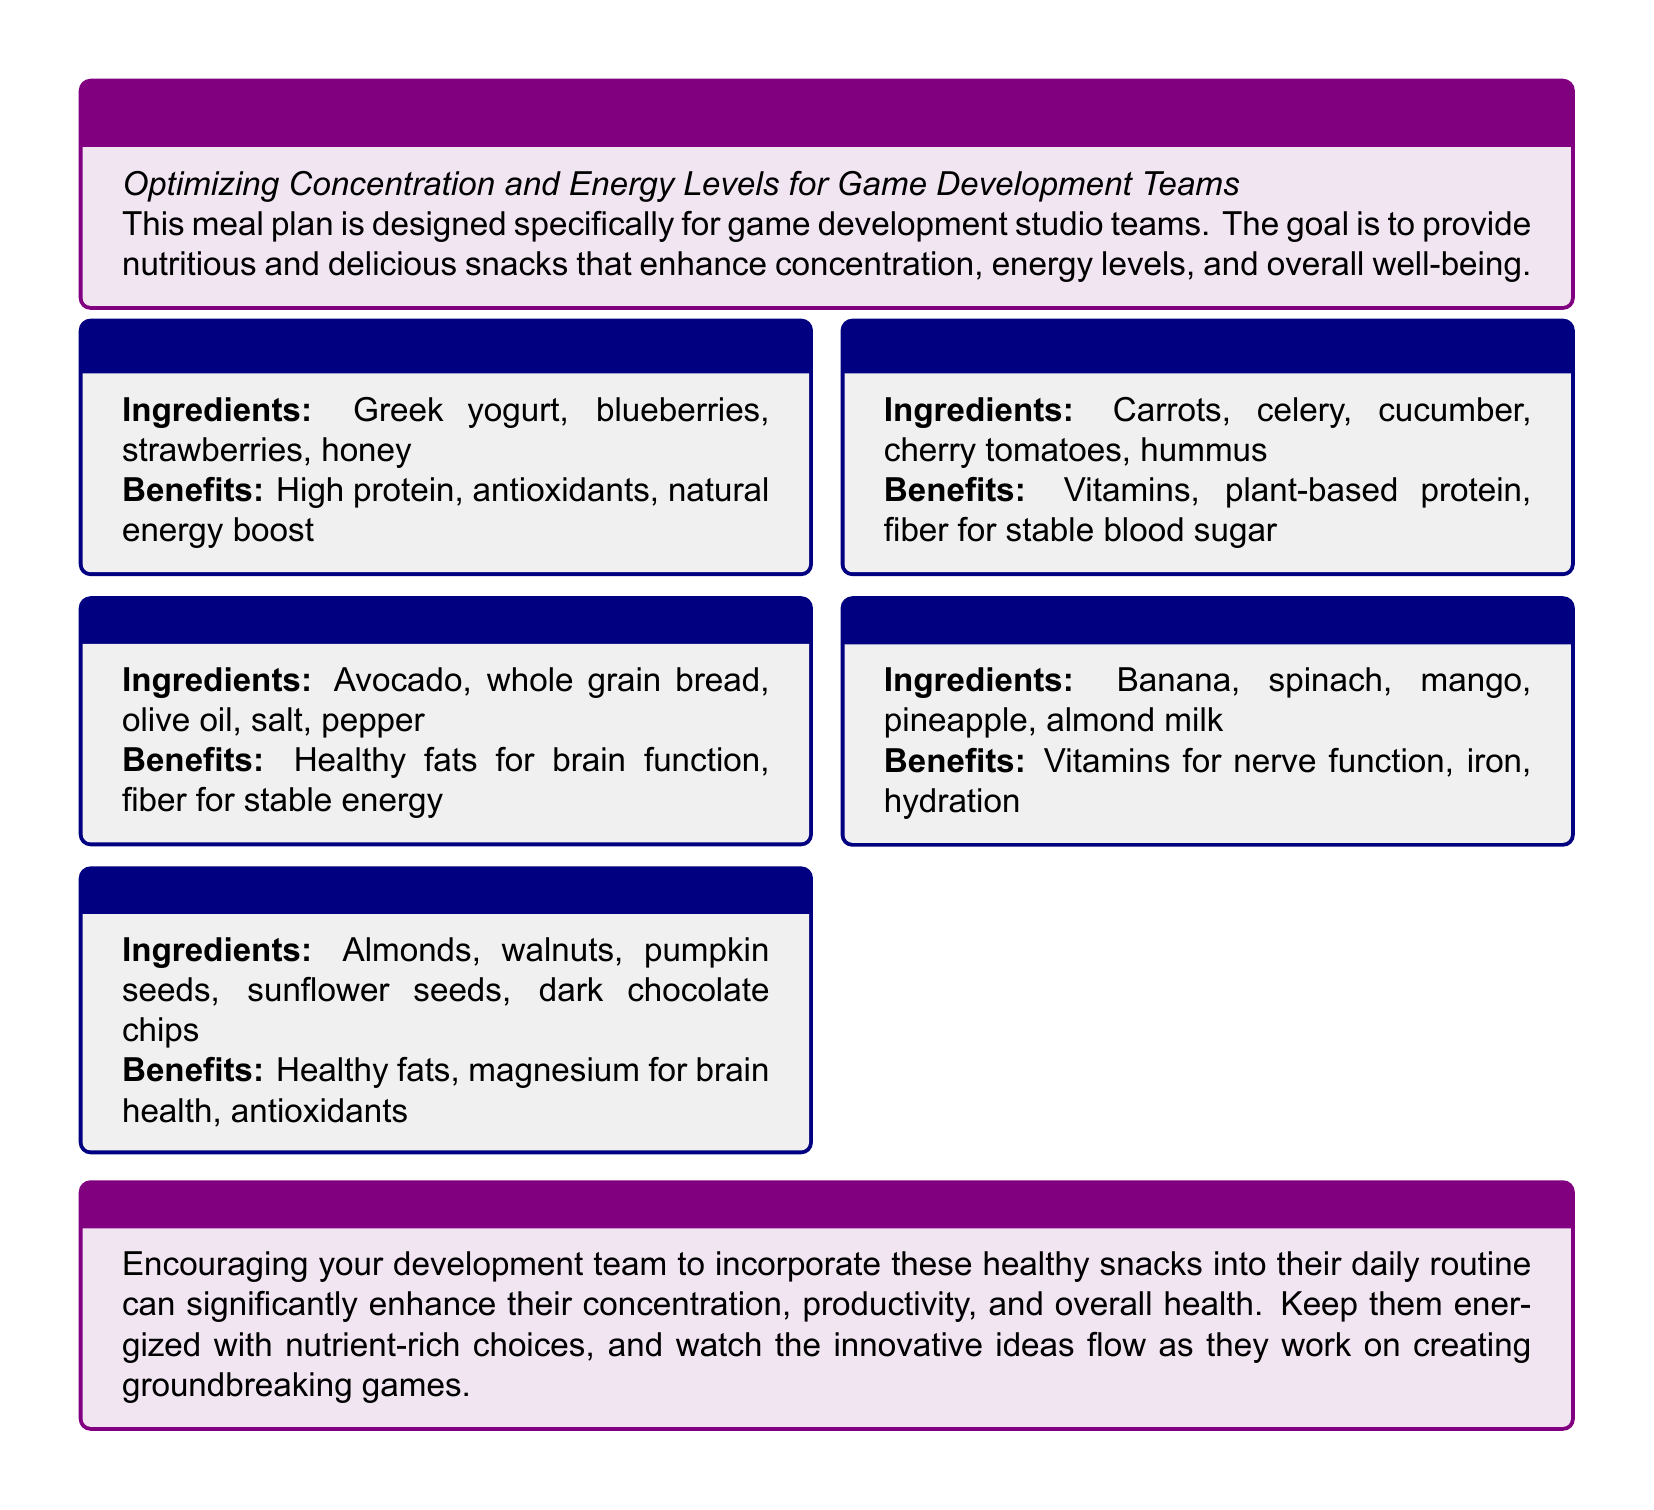What is the first snack listed in the meal plan? The first snack listed is "Greek Yogurt with Berries."
Answer: Greek Yogurt with Berries What are the ingredients of Avocado Toast? The ingredients are avocado, whole grain bread, olive oil, salt, pepper.
Answer: Avocado, whole grain bread, olive oil, salt, pepper Which snack contains magnesium for brain health? The snack that contains magnesium for brain health is "Trail Mix."
Answer: Trail Mix How many snacks are listed in the meal plan? The meal plan lists five different snacks.
Answer: Five What is the main benefit of Fresh Fruit Smoothie? The main benefit of Fresh Fruit Smoothie is vitamins for nerve function.
Answer: Vitamins for nerve function Which ingredient in Veggie Sticks & Hummus provides plant-based protein? The ingredient providing plant-based protein is hummus.
Answer: Hummus 